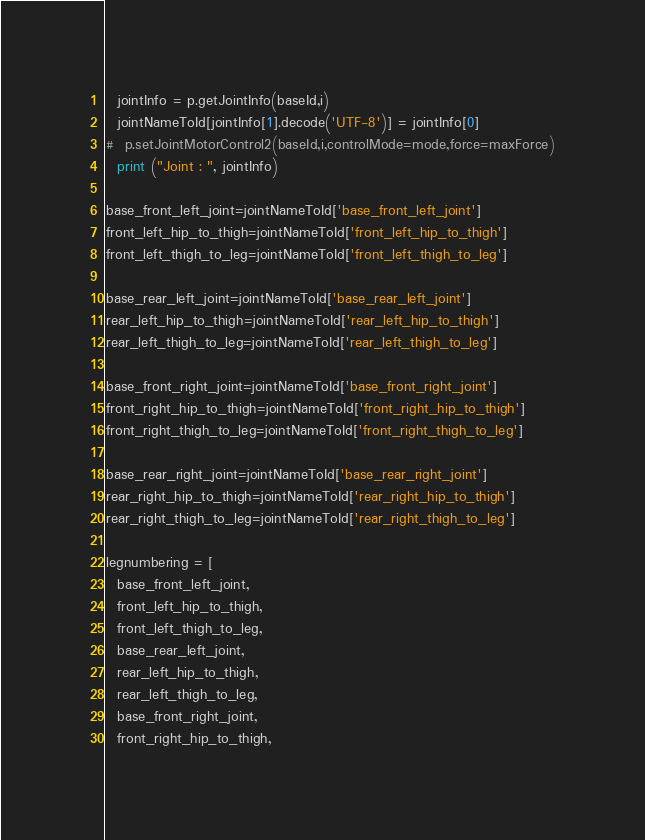<code> <loc_0><loc_0><loc_500><loc_500><_Python_>  jointInfo = p.getJointInfo(baseId,i)
  jointNameToId[jointInfo[1].decode('UTF-8')] = jointInfo[0]
#  p.setJointMotorControl2(baseId,i,controlMode=mode,force=maxForce)
  print ("Joint : ", jointInfo)

base_front_left_joint=jointNameToId['base_front_left_joint']
front_left_hip_to_thigh=jointNameToId['front_left_hip_to_thigh']
front_left_thigh_to_leg=jointNameToId['front_left_thigh_to_leg']

base_rear_left_joint=jointNameToId['base_rear_left_joint']
rear_left_hip_to_thigh=jointNameToId['rear_left_hip_to_thigh']
rear_left_thigh_to_leg=jointNameToId['rear_left_thigh_to_leg']

base_front_right_joint=jointNameToId['base_front_right_joint']
front_right_hip_to_thigh=jointNameToId['front_right_hip_to_thigh']
front_right_thigh_to_leg=jointNameToId['front_right_thigh_to_leg']

base_rear_right_joint=jointNameToId['base_rear_right_joint']
rear_right_hip_to_thigh=jointNameToId['rear_right_hip_to_thigh']
rear_right_thigh_to_leg=jointNameToId['rear_right_thigh_to_leg']

legnumbering = [
  base_front_left_joint,
  front_left_hip_to_thigh,
  front_left_thigh_to_leg,
  base_rear_left_joint,
  rear_left_hip_to_thigh,
  rear_left_thigh_to_leg,
  base_front_right_joint,
  front_right_hip_to_thigh,</code> 